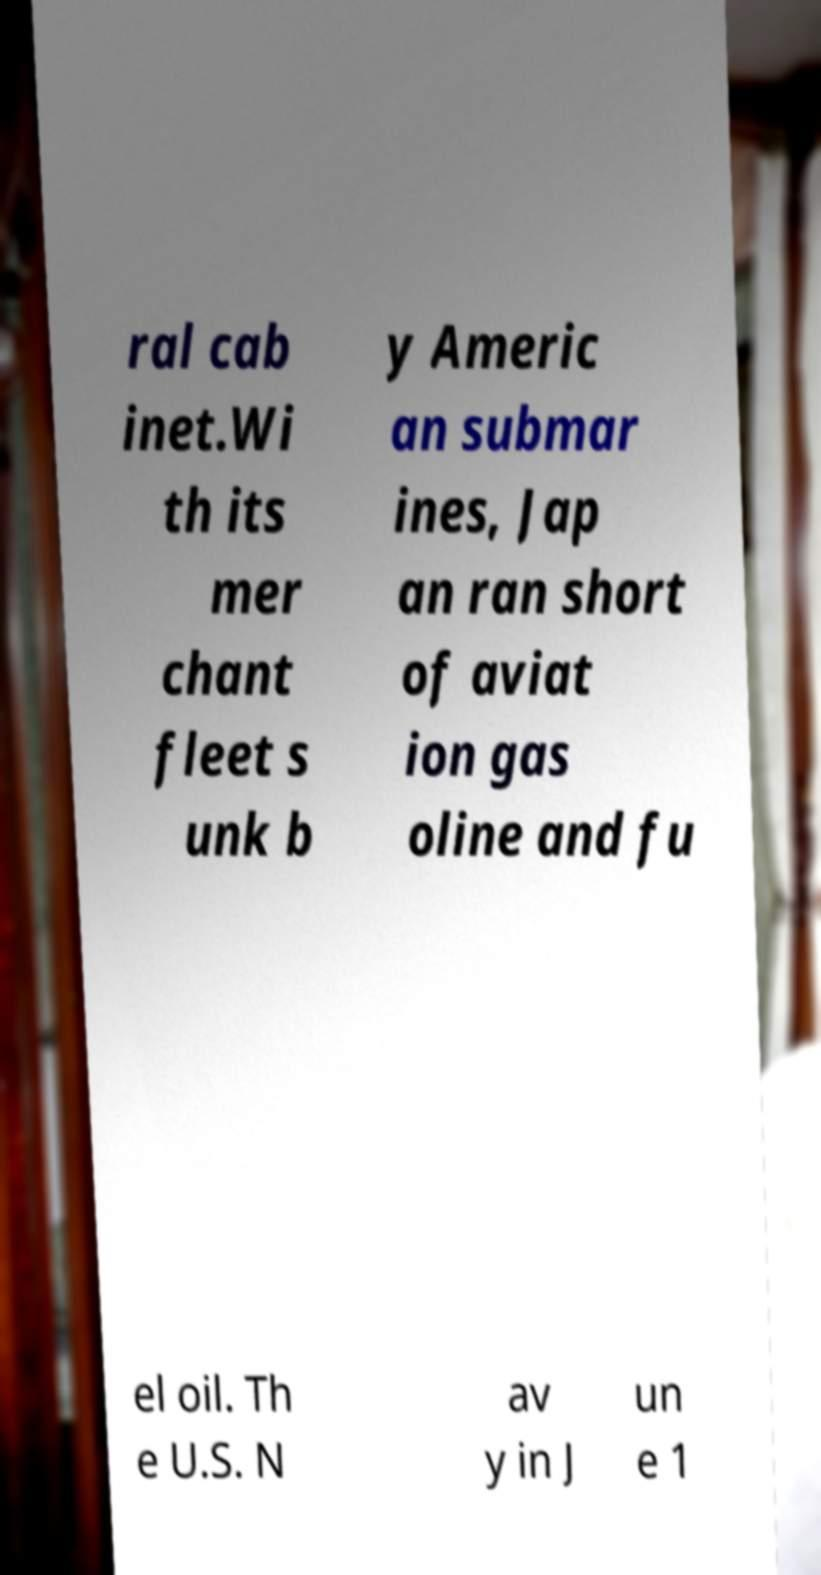There's text embedded in this image that I need extracted. Can you transcribe it verbatim? ral cab inet.Wi th its mer chant fleet s unk b y Americ an submar ines, Jap an ran short of aviat ion gas oline and fu el oil. Th e U.S. N av y in J un e 1 